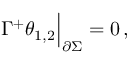Convert formula to latex. <formula><loc_0><loc_0><loc_500><loc_500>\Gamma ^ { + } \theta _ { 1 , 2 } \Big | _ { \partial \Sigma } = 0 \, ,</formula> 